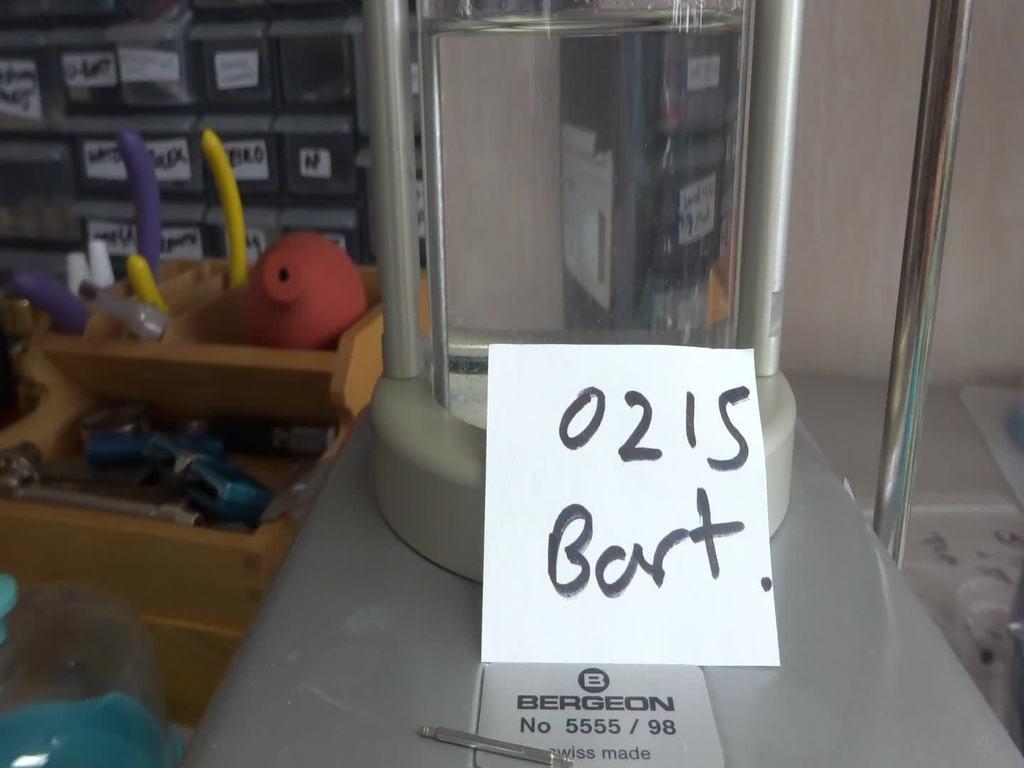Please provide a concise description of this image. In the foreground of this image, there is an object and a paper on it. On the left there are tools in the basket and white boxes in the rack. On the right background, there is a wall. 